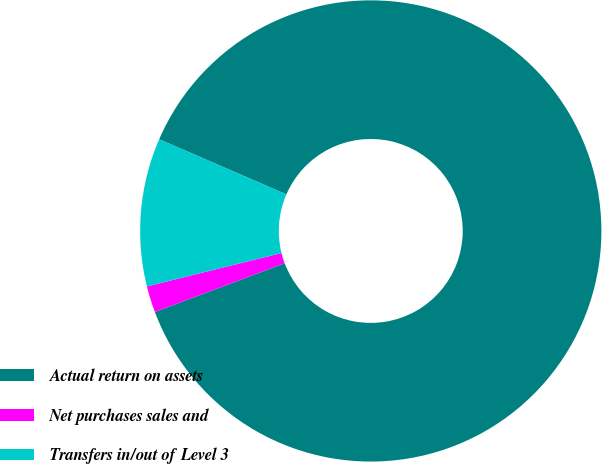Convert chart. <chart><loc_0><loc_0><loc_500><loc_500><pie_chart><fcel>Actual return on assets<fcel>Net purchases sales and<fcel>Transfers in/out of Level 3<nl><fcel>87.78%<fcel>1.85%<fcel>10.37%<nl></chart> 